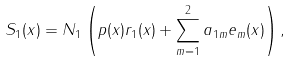<formula> <loc_0><loc_0><loc_500><loc_500>S _ { 1 } ( x ) = N _ { 1 } \left ( p ( x ) r _ { 1 } ( x ) + \sum _ { m = 1 } ^ { 2 } a _ { 1 m } e _ { m } ( x ) \right ) ,</formula> 